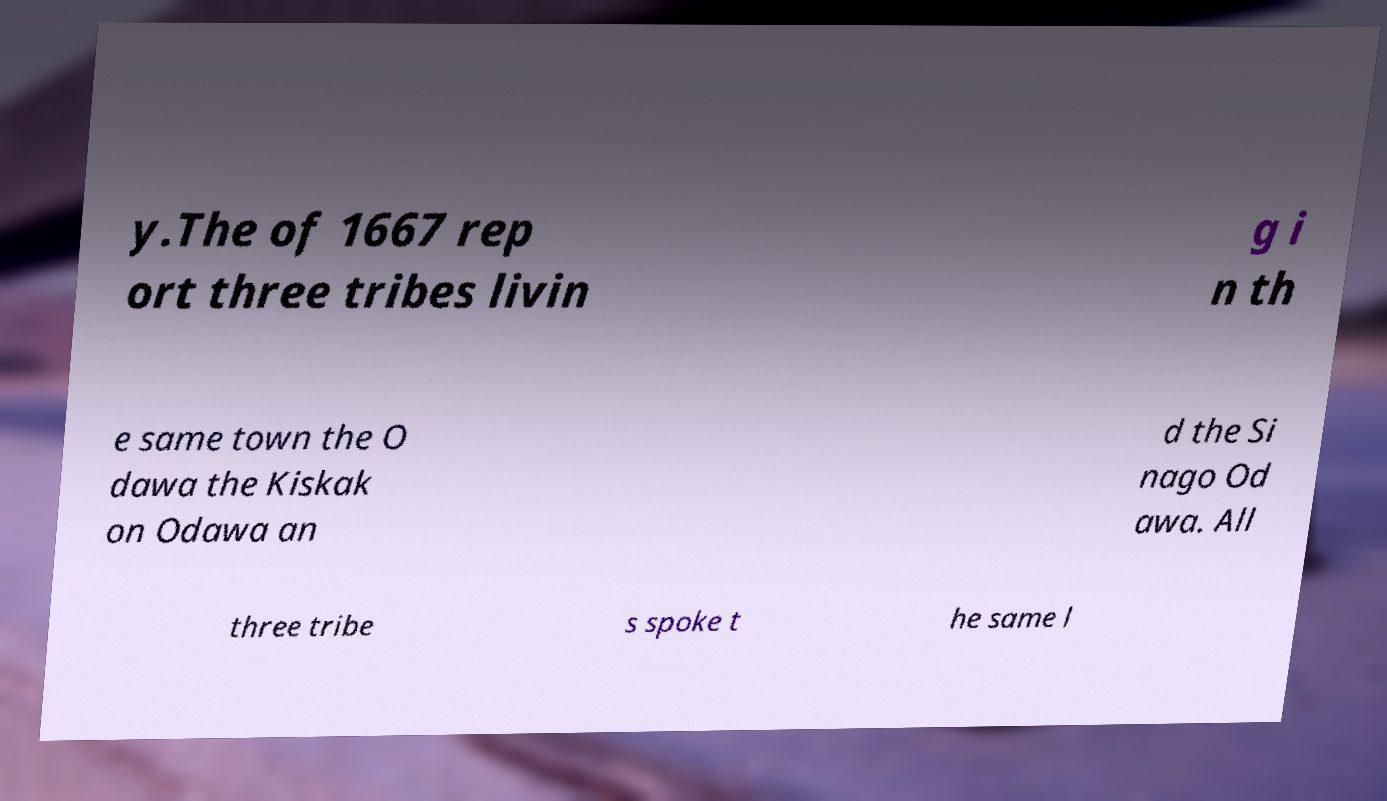Could you assist in decoding the text presented in this image and type it out clearly? y.The of 1667 rep ort three tribes livin g i n th e same town the O dawa the Kiskak on Odawa an d the Si nago Od awa. All three tribe s spoke t he same l 